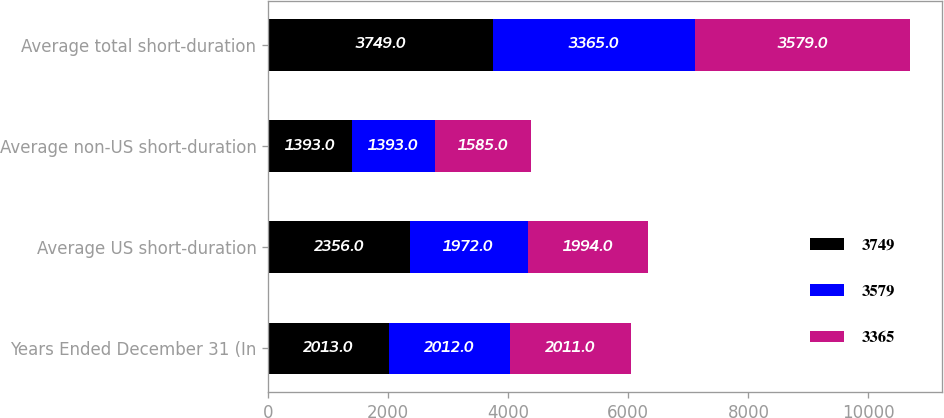Convert chart. <chart><loc_0><loc_0><loc_500><loc_500><stacked_bar_chart><ecel><fcel>Years Ended December 31 (In<fcel>Average US short-duration<fcel>Average non-US short-duration<fcel>Average total short-duration<nl><fcel>3749<fcel>2013<fcel>2356<fcel>1393<fcel>3749<nl><fcel>3579<fcel>2012<fcel>1972<fcel>1393<fcel>3365<nl><fcel>3365<fcel>2011<fcel>1994<fcel>1585<fcel>3579<nl></chart> 